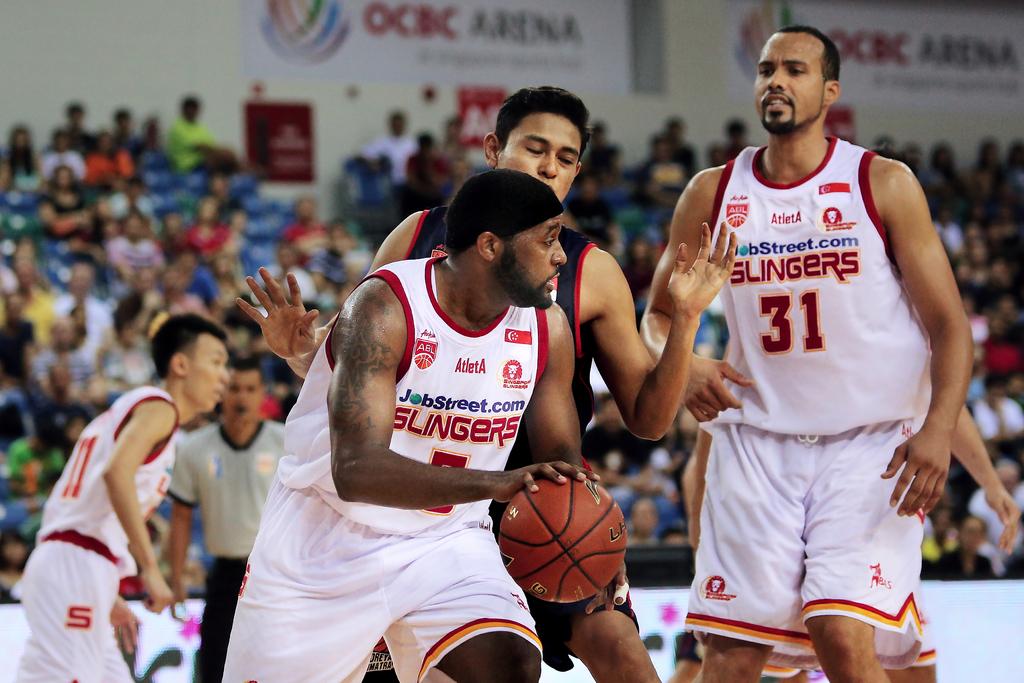What is the name of the basketball team?
Ensure brevity in your answer.  Slingers. What is the number on the jersey to the right?
Provide a short and direct response. 31. 